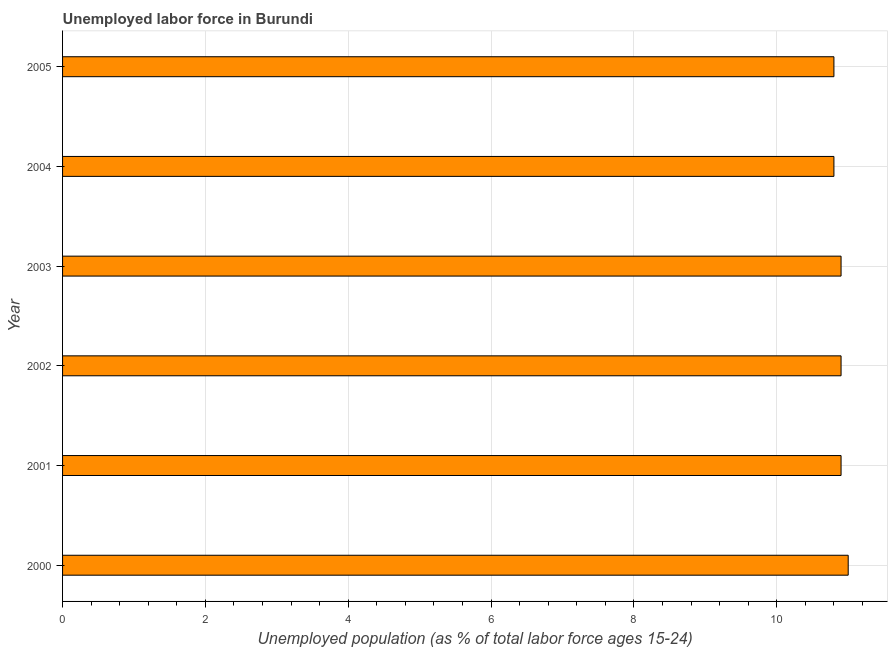Does the graph contain grids?
Provide a short and direct response. Yes. What is the title of the graph?
Your response must be concise. Unemployed labor force in Burundi. What is the label or title of the X-axis?
Your answer should be very brief. Unemployed population (as % of total labor force ages 15-24). What is the total unemployed youth population in 2005?
Provide a short and direct response. 10.8. Across all years, what is the minimum total unemployed youth population?
Offer a very short reply. 10.8. In which year was the total unemployed youth population maximum?
Your answer should be compact. 2000. What is the sum of the total unemployed youth population?
Offer a terse response. 65.3. What is the difference between the total unemployed youth population in 2000 and 2004?
Provide a short and direct response. 0.2. What is the average total unemployed youth population per year?
Make the answer very short. 10.88. What is the median total unemployed youth population?
Make the answer very short. 10.9. In how many years, is the total unemployed youth population greater than 5.6 %?
Keep it short and to the point. 6. What is the ratio of the total unemployed youth population in 2000 to that in 2005?
Offer a very short reply. 1.02. Is the total unemployed youth population in 2000 less than that in 2005?
Provide a succinct answer. No. Is the difference between the total unemployed youth population in 2001 and 2002 greater than the difference between any two years?
Ensure brevity in your answer.  No. In how many years, is the total unemployed youth population greater than the average total unemployed youth population taken over all years?
Your response must be concise. 4. How many bars are there?
Your answer should be compact. 6. Are all the bars in the graph horizontal?
Offer a terse response. Yes. How many years are there in the graph?
Ensure brevity in your answer.  6. What is the Unemployed population (as % of total labor force ages 15-24) in 2000?
Give a very brief answer. 11. What is the Unemployed population (as % of total labor force ages 15-24) of 2001?
Keep it short and to the point. 10.9. What is the Unemployed population (as % of total labor force ages 15-24) of 2002?
Give a very brief answer. 10.9. What is the Unemployed population (as % of total labor force ages 15-24) in 2003?
Your answer should be very brief. 10.9. What is the Unemployed population (as % of total labor force ages 15-24) of 2004?
Give a very brief answer. 10.8. What is the Unemployed population (as % of total labor force ages 15-24) of 2005?
Your response must be concise. 10.8. What is the difference between the Unemployed population (as % of total labor force ages 15-24) in 2000 and 2001?
Ensure brevity in your answer.  0.1. What is the difference between the Unemployed population (as % of total labor force ages 15-24) in 2000 and 2003?
Your response must be concise. 0.1. What is the difference between the Unemployed population (as % of total labor force ages 15-24) in 2001 and 2002?
Give a very brief answer. 0. What is the difference between the Unemployed population (as % of total labor force ages 15-24) in 2002 and 2003?
Make the answer very short. 0. What is the difference between the Unemployed population (as % of total labor force ages 15-24) in 2002 and 2004?
Your answer should be compact. 0.1. What is the difference between the Unemployed population (as % of total labor force ages 15-24) in 2004 and 2005?
Offer a terse response. 0. What is the ratio of the Unemployed population (as % of total labor force ages 15-24) in 2000 to that in 2001?
Provide a short and direct response. 1.01. What is the ratio of the Unemployed population (as % of total labor force ages 15-24) in 2000 to that in 2002?
Make the answer very short. 1.01. What is the ratio of the Unemployed population (as % of total labor force ages 15-24) in 2000 to that in 2003?
Your answer should be very brief. 1.01. What is the ratio of the Unemployed population (as % of total labor force ages 15-24) in 2000 to that in 2005?
Keep it short and to the point. 1.02. What is the ratio of the Unemployed population (as % of total labor force ages 15-24) in 2001 to that in 2002?
Keep it short and to the point. 1. What is the ratio of the Unemployed population (as % of total labor force ages 15-24) in 2001 to that in 2003?
Provide a short and direct response. 1. What is the ratio of the Unemployed population (as % of total labor force ages 15-24) in 2001 to that in 2004?
Make the answer very short. 1.01. What is the ratio of the Unemployed population (as % of total labor force ages 15-24) in 2001 to that in 2005?
Make the answer very short. 1.01. What is the ratio of the Unemployed population (as % of total labor force ages 15-24) in 2003 to that in 2005?
Your answer should be compact. 1.01. What is the ratio of the Unemployed population (as % of total labor force ages 15-24) in 2004 to that in 2005?
Ensure brevity in your answer.  1. 